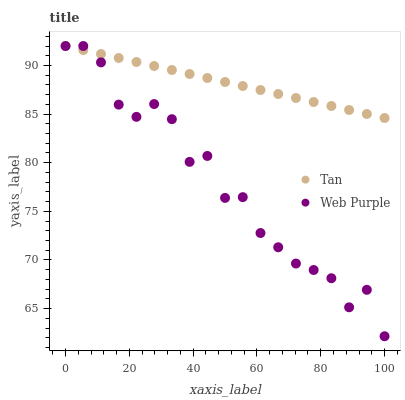Does Web Purple have the minimum area under the curve?
Answer yes or no. Yes. Does Tan have the maximum area under the curve?
Answer yes or no. Yes. Does Web Purple have the maximum area under the curve?
Answer yes or no. No. Is Tan the smoothest?
Answer yes or no. Yes. Is Web Purple the roughest?
Answer yes or no. Yes. Is Web Purple the smoothest?
Answer yes or no. No. Does Web Purple have the lowest value?
Answer yes or no. Yes. Does Web Purple have the highest value?
Answer yes or no. Yes. Does Web Purple intersect Tan?
Answer yes or no. Yes. Is Web Purple less than Tan?
Answer yes or no. No. Is Web Purple greater than Tan?
Answer yes or no. No. 